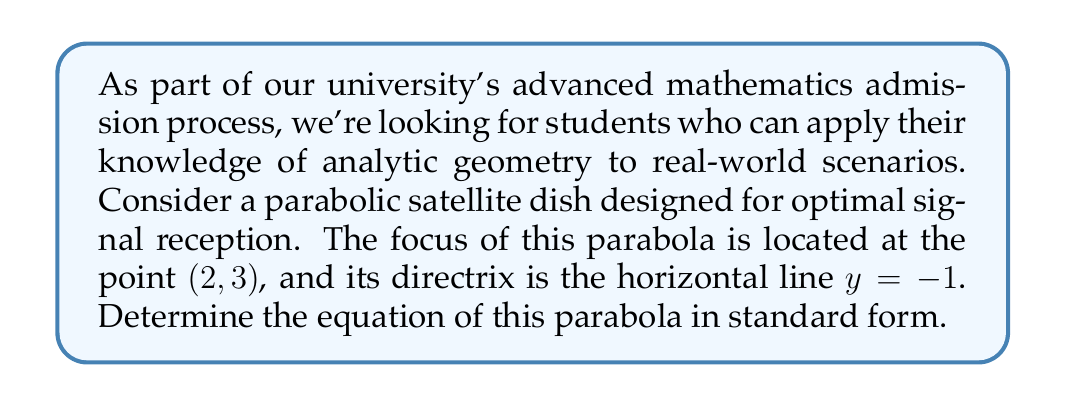Solve this math problem. Let's approach this step-by-step:

1) The general equation of a parabola with a vertical axis of symmetry is:
   $$(x - h)^2 = 4p(y - k)$$
   where $(h, k)$ is the vertex and $p$ is the distance from the vertex to the focus.

2) We know the focus is at $(2, 3)$. Let's call the vertex $(h, k)$.

3) The distance from the focus to the directrix is $4p$. We can calculate this:
   $4p = 3 - (-1) = 4$
   Therefore, $p = 1$

4) The vertex is halfway between the focus and the directrix:
   $k = \frac{3 + (-1)}{2} = 1$

5) Since the focus is at $(2, 3)$ and the vertex is at $(h, 1)$, we know that $h = 2$.

6) Now we have all the components to form our equation:
   $$(x - 2)^2 = 4(1)(y - 1)$$

7) Simplify:
   $$(x - 2)^2 = 4(y - 1)$$

This is the equation of the parabola in standard form.
Answer: $(x - 2)^2 = 4(y - 1)$ 